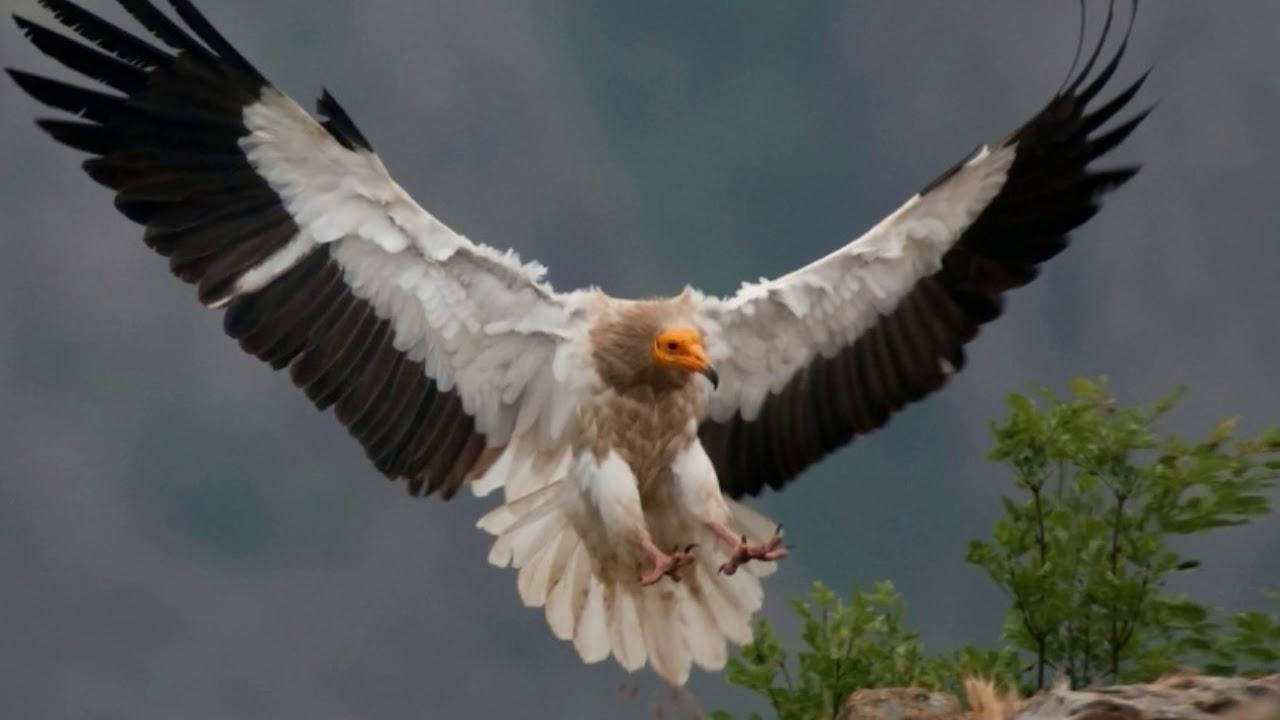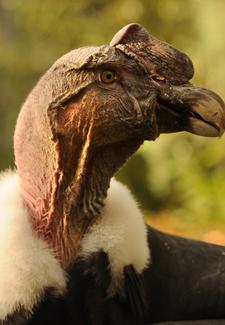The first image is the image on the left, the second image is the image on the right. Examine the images to the left and right. Is the description "Both turkey vultures are standing on a tree branch" accurate? Answer yes or no. No. The first image is the image on the left, the second image is the image on the right. For the images shown, is this caption "There is one large bird with black and white feathers that has its wings spread." true? Answer yes or no. Yes. 